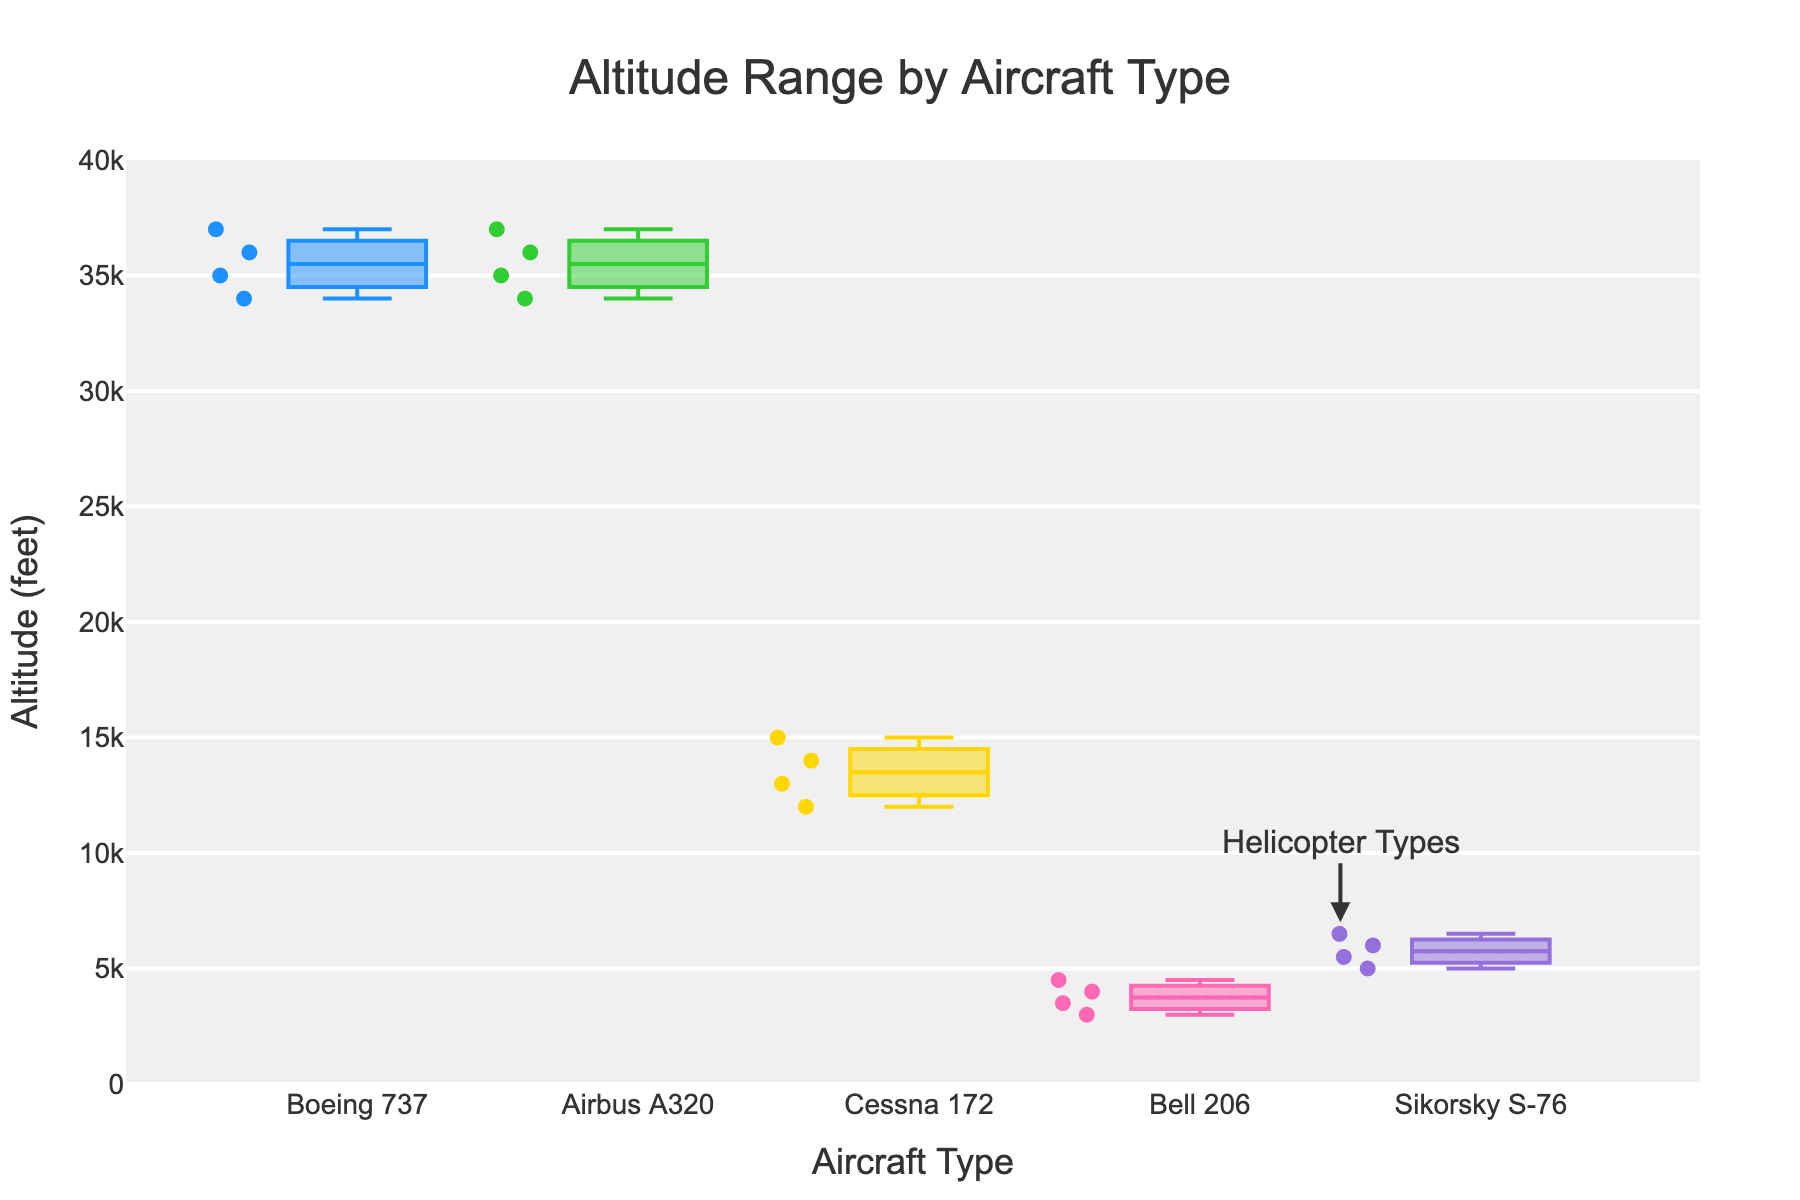How many types of aircraft are represented in the plot? The figure's x-axis shows the names of the aircraft, and by counting them there are five different types: Boeing 737, Airbus A320, Cessna 172, Bell 206, and Sikorsky S-76.
Answer: 5 What is the range of altitudes flown by the Boeing 737? From the box plot, the lowest point (minimum) is 34,000 feet and the highest point (maximum) is 37,000 feet. The range is calculated as maximum minus minimum: 37,000 - 34,000.
Answer: 3,000 feet Which aircraft type has the highest median altitude? The figure shows a line inside each box representing the median. The Boeing 737 has the highest median line positioned at 35,500 feet.
Answer: Boeing 737 What is the interquartile range (IQR) for the Sikorsky S-76? The IQR is the difference between the third quartile (Q3) and the first quartile (Q1). From the plot, Q1 is at 5,250 feet and Q3 is at 6,250 feet, making IQR = Q3 - Q1 = 6,250 - 5,250.
Answer: 1,000 feet Which aircraft type shows the largest spread in altitude values? By comparing the lengths of the boxes and their whiskers in the figure, the Airbus A320 shows the largest spread of altitudes from around 34,000 feet to 37,000 feet, giving a range of 3,000 feet.
Answer: Airbus A320 Are there any outliers present in the Sikorsky S-76 data? Outliers would be represented as individual points outside the whiskers of the box plot. For the Sikorsky S-76, there are no such points visible in the plot, indicating no outliers.
Answer: No Which helicopter type flies at the highest median altitude? The plots for helicopters include Bell 206 and Sikorsky S-76. The Sikorsky S-76 has the higher median line, around 5,500 feet compared to Bell 206, which is around 3,750 feet.
Answer: Sikorsky S-76 What is the mean altitude for the Bell 206? The box plot includes a mark for the mean. For the Bell 206, the mean line (diamond shape) is at approximately 3,750 feet.
Answer: 3,750 feet How does the altitude variance for Cessna 172 compare to that for Bell 206? By observing the spread of the boxes, the Bell 206 altitudes range from about 3,000 to 4,500 feet, while the Cessna 172 ranges from 12,000 to 15,000 feet, both showing similar variances but different ranges.
Answer: Similar variance What does the annotation "Helicopter Types" refer to in the plot? The arrow and annotation in the plot point to Bell 206 and Sikorsky S-76, indicating these are the helicopter types among the aircraft plotted.
Answer: Bell 206 and Sikorsky S-76 